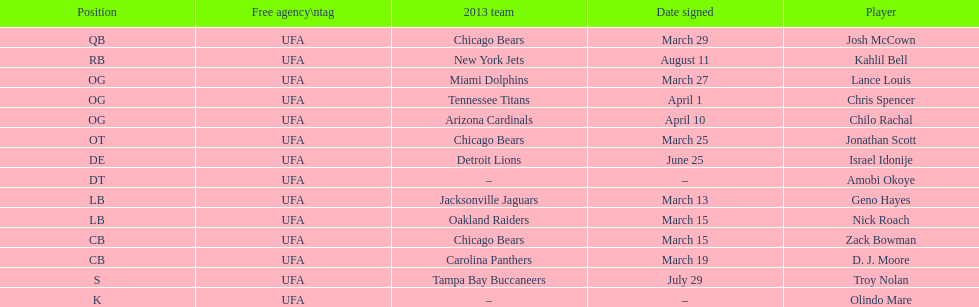Their first name is identical to a country's name. Israel Idonije. 